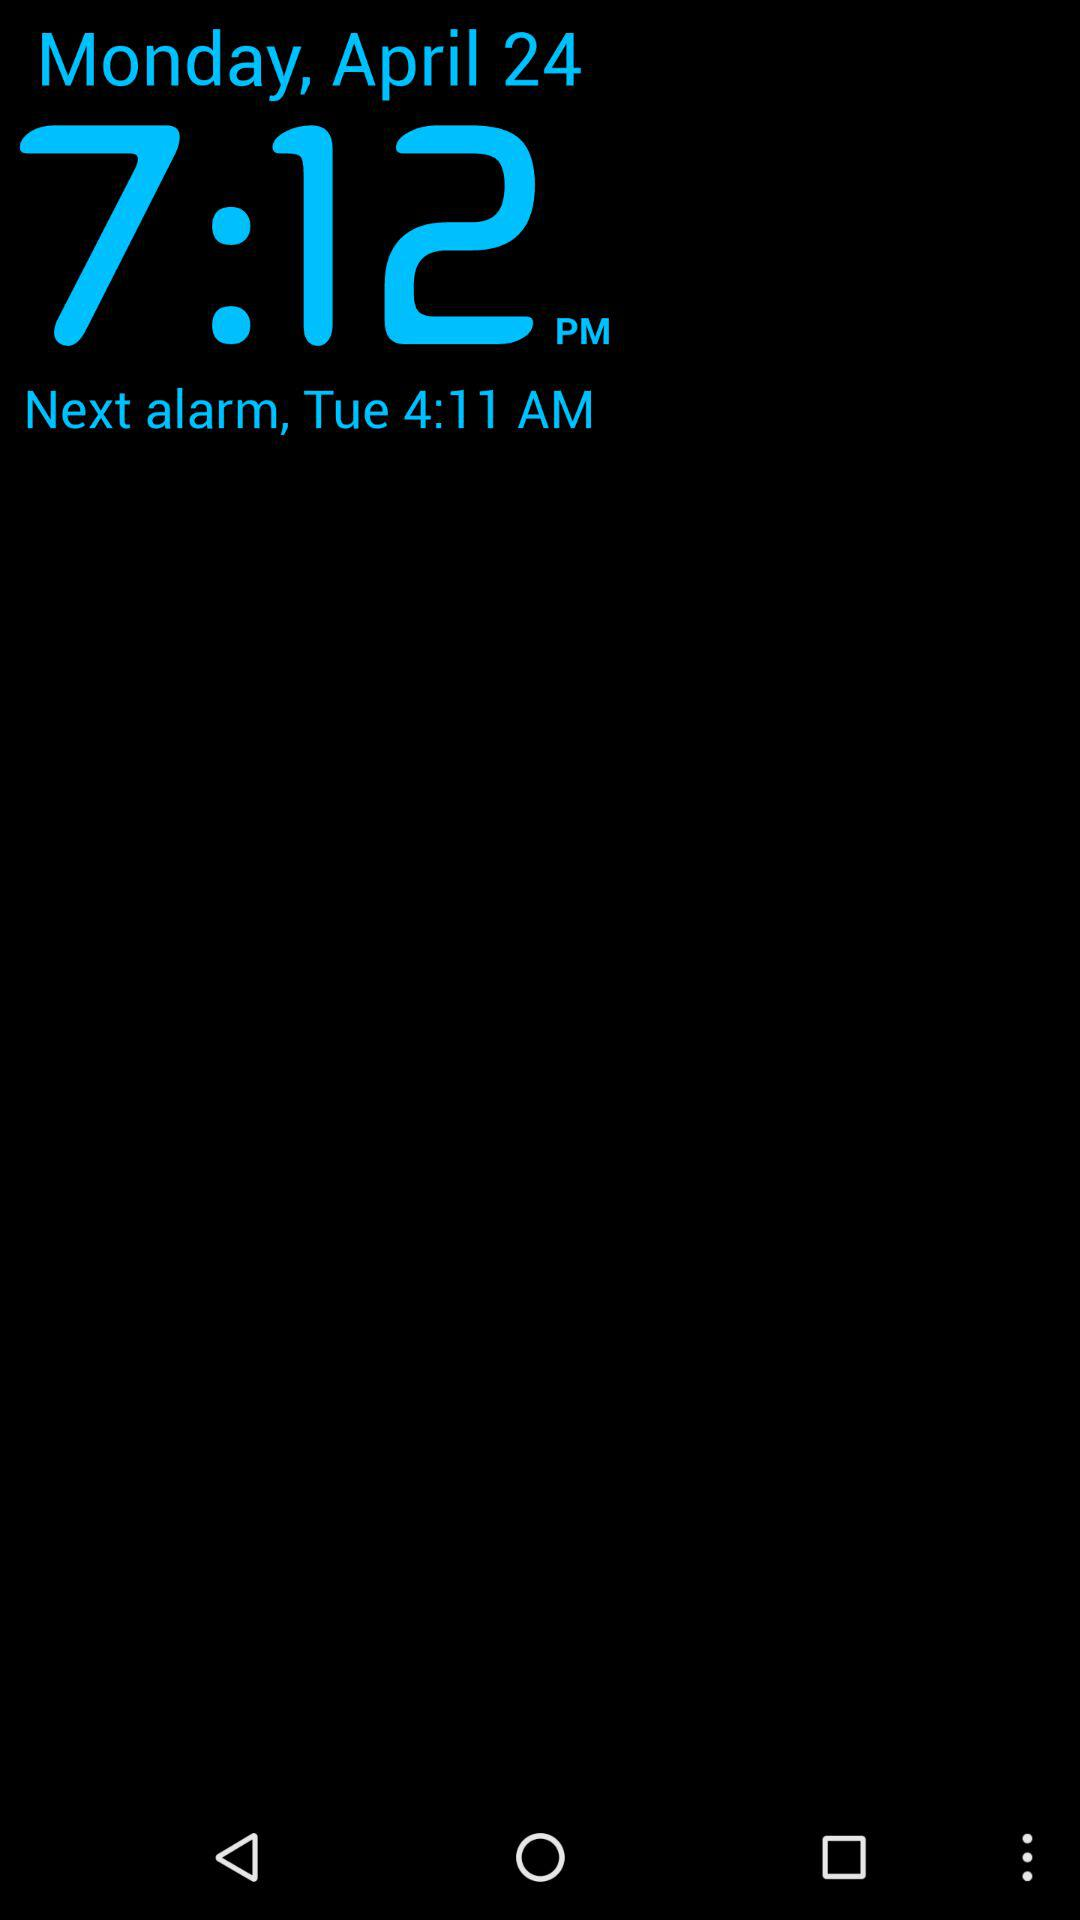What is the current alarm time? The current alarm time is 7:12 p.m. 